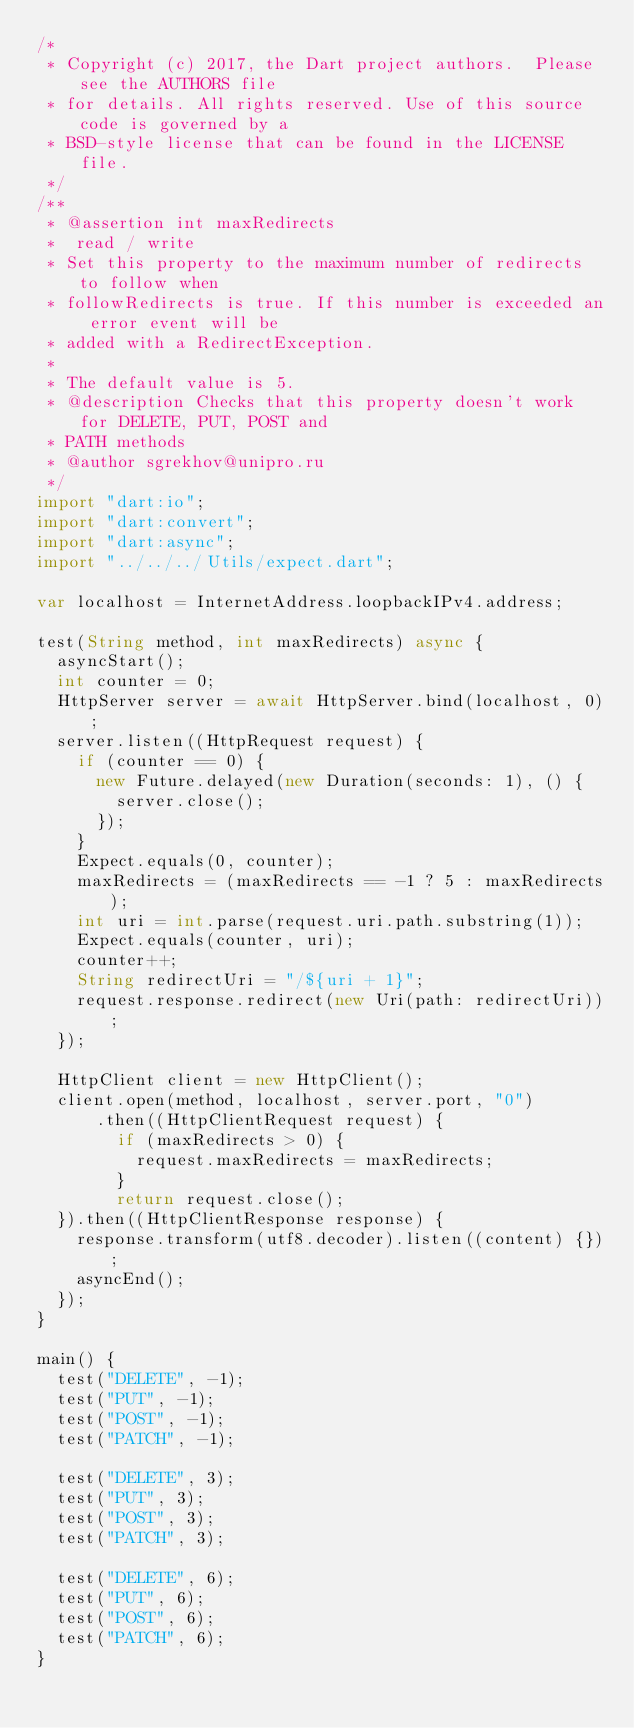Convert code to text. <code><loc_0><loc_0><loc_500><loc_500><_Dart_>/*
 * Copyright (c) 2017, the Dart project authors.  Please see the AUTHORS file
 * for details. All rights reserved. Use of this source code is governed by a
 * BSD-style license that can be found in the LICENSE file.
 */
/**
 * @assertion int maxRedirects
 *  read / write
 * Set this property to the maximum number of redirects to follow when
 * followRedirects is true. If this number is exceeded an error event will be
 * added with a RedirectException.
 *
 * The default value is 5.
 * @description Checks that this property doesn't work for DELETE, PUT, POST and
 * PATH methods
 * @author sgrekhov@unipro.ru
 */
import "dart:io";
import "dart:convert";
import "dart:async";
import "../../../Utils/expect.dart";

var localhost = InternetAddress.loopbackIPv4.address;

test(String method, int maxRedirects) async {
  asyncStart();
  int counter = 0;
  HttpServer server = await HttpServer.bind(localhost, 0);
  server.listen((HttpRequest request) {
    if (counter == 0) {
      new Future.delayed(new Duration(seconds: 1), () {
        server.close();
      });
    }
    Expect.equals(0, counter);
    maxRedirects = (maxRedirects == -1 ? 5 : maxRedirects);
    int uri = int.parse(request.uri.path.substring(1));
    Expect.equals(counter, uri);
    counter++;
    String redirectUri = "/${uri + 1}";
    request.response.redirect(new Uri(path: redirectUri));
  });

  HttpClient client = new HttpClient();
  client.open(method, localhost, server.port, "0")
      .then((HttpClientRequest request) {
        if (maxRedirects > 0) {
          request.maxRedirects = maxRedirects;
        }
        return request.close();
  }).then((HttpClientResponse response) {
    response.transform(utf8.decoder).listen((content) {});
    asyncEnd();
  });
}

main() {
  test("DELETE", -1);
  test("PUT", -1);
  test("POST", -1);
  test("PATCH", -1);

  test("DELETE", 3);
  test("PUT", 3);
  test("POST", 3);
  test("PATCH", 3);

  test("DELETE", 6);
  test("PUT", 6);
  test("POST", 6);
  test("PATCH", 6);
}
</code> 